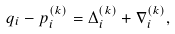<formula> <loc_0><loc_0><loc_500><loc_500>q _ { i } - p _ { i } ^ { ( k ) } = \Delta _ { i } ^ { ( k ) } + \nabla _ { i } ^ { ( k ) } ,</formula> 